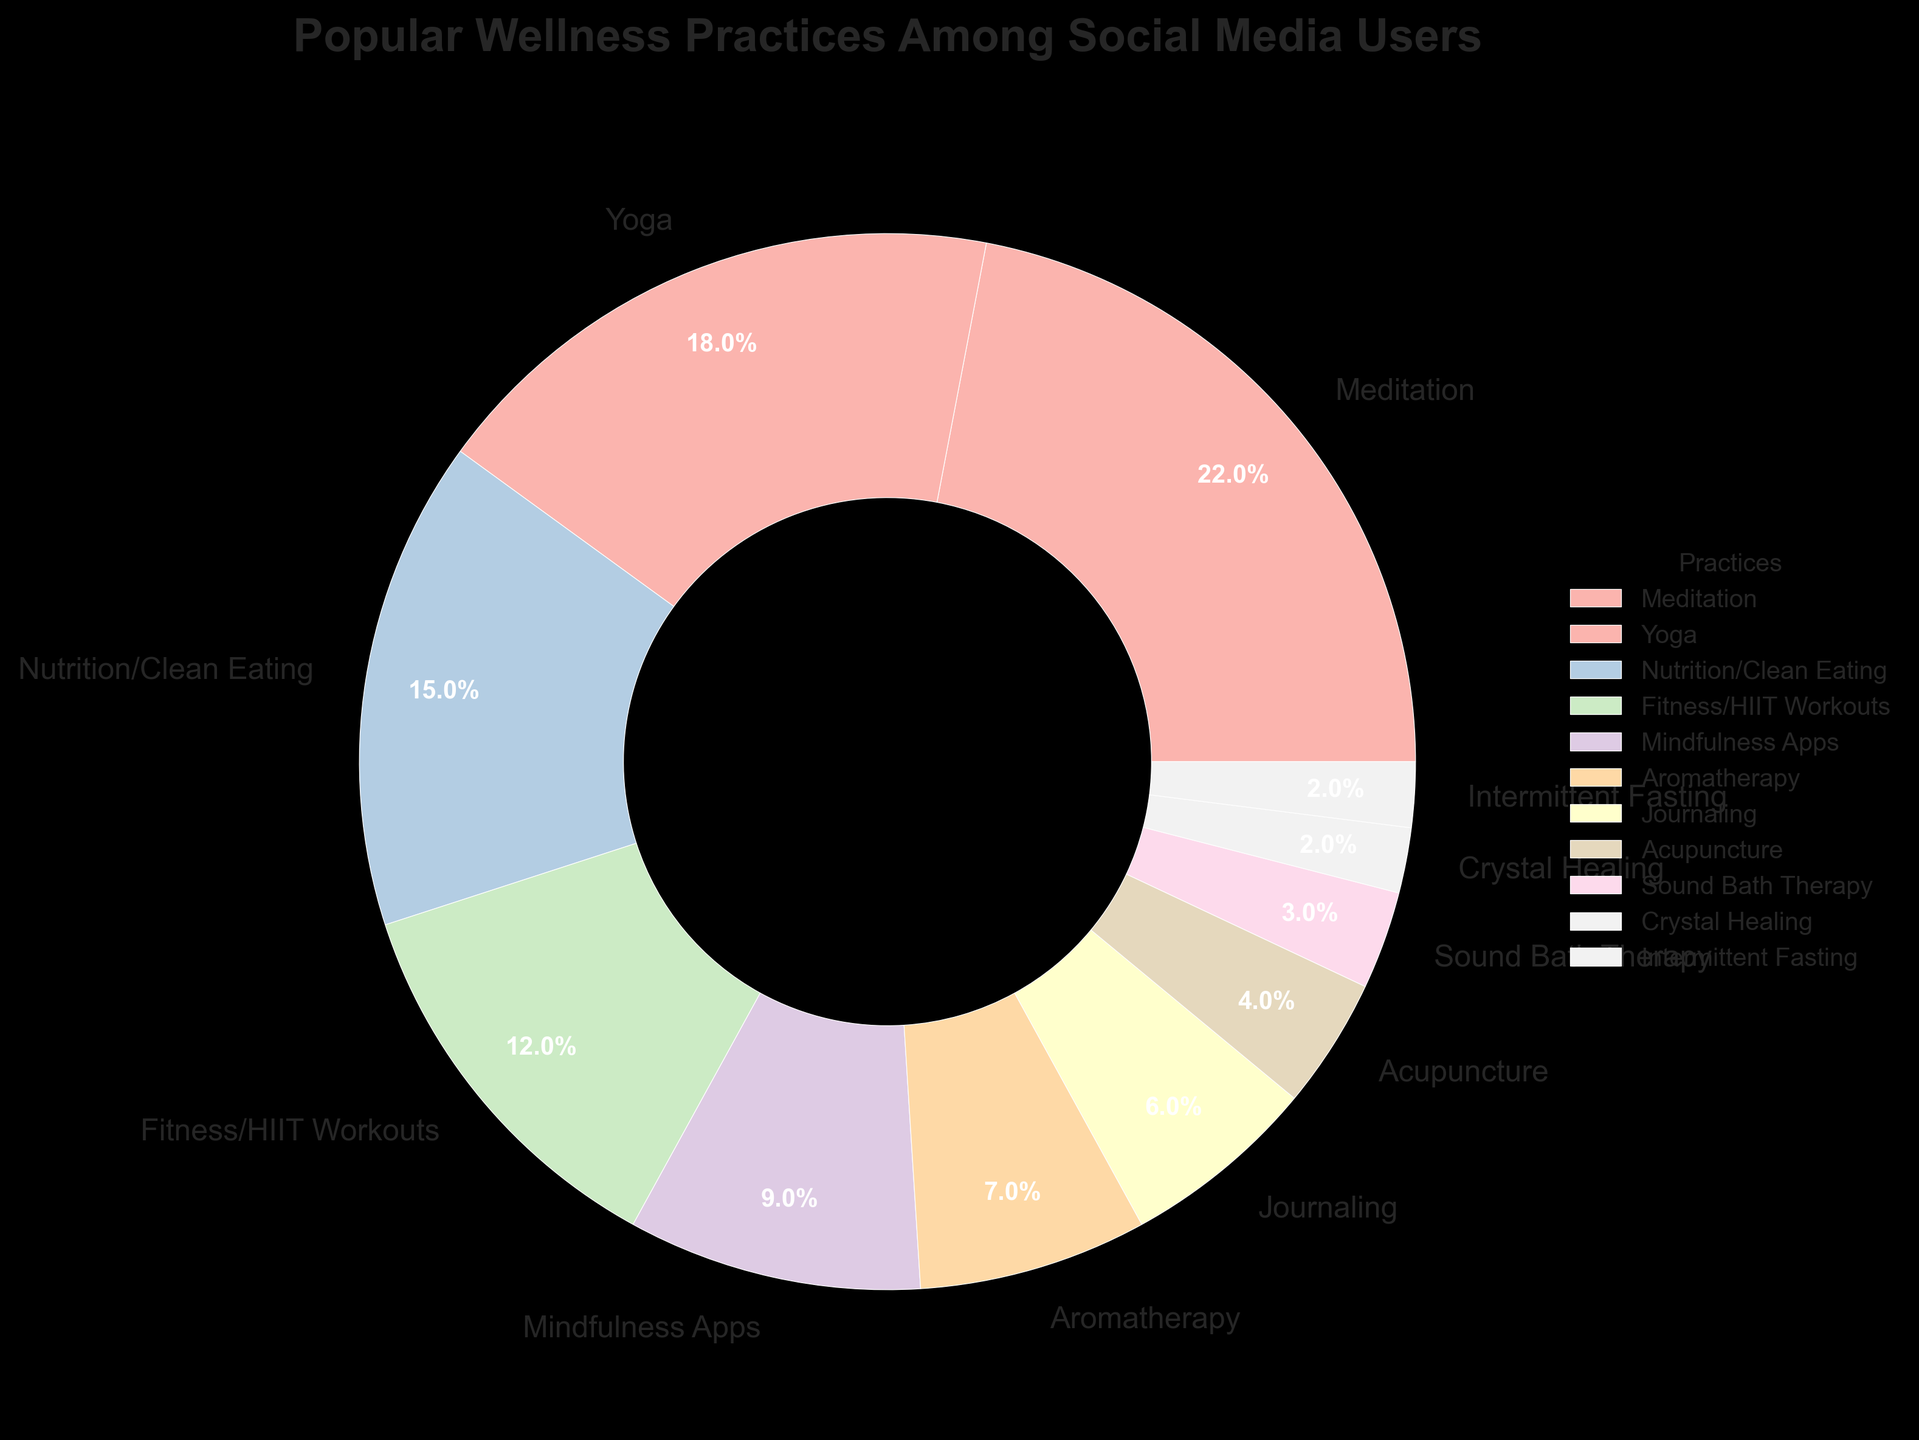What is the most popular wellness practice among social media users? The largest section of the pie chart represents the most popular wellness practice. Meditation occupies the largest portion of the chart. Therefore, the most popular wellness practice is Meditation.
Answer: Meditation Which wellness practice has a percentage of 9%? By examining the labels in the pie chart, we can find that Mindfulness Apps is the practice labeled with 9%.
Answer: Mindfulness Apps How much more popular is meditation compared to crystal healing? Meditation has a percentage of 22%, and Crystal Healing has a percentage of 2%. The difference in popularity is 22% - 2%, which results in 20%.
Answer: 20% What percent of users practice Yoga or Journaling? Yoga has a percentage of 18%, and Journaling has 6%. By adding these percentages, 18% + 6%, we get 24%.
Answer: 24% Which practice has the smallest representation in the pie chart? The smallest segment in the pie chart represents the practice with the smallest percentage. Crystal Healing occupies the smallest segment with 2%.
Answer: Crystal Healing How do the combined percentages of Fitness/HIIT Workouts and Nutrition/Clean Eating compare to Meditation? Fitness/HIIT Workouts has a percentage of 12% and Nutrition/Clean Eating has 15%. Combined, this is 12% + 15% = 27%. Meditation alone is 22%. Therefore, the combined percentage (27%) is greater than Meditation (22%).
Answer: 27% > 22% Identify two practices that together make up exactly 15% of the wellness practices. Upon examining the pie chart, we find that Acupuncture and Sound Bath Therapy represent percentages of 4% and 3% respectively. Together, 4% + 3% = 7%, which isn't sufficient. Similarly, no other combination of two practices sums exactly to 15%. But reviewing Journerling (6%) and Aromatherapy (9%) we get 6% + 9% = 15%
Answer: Journaling and Aromatherapy What is the difference in percentage between Yoga and Acupuncture? Yoga has a percentage of 18%, while Acupuncture has 4%. By subtracting the smaller value from the larger one, 18% - 4%, the difference in percentage is 14%.
Answer: 14% Which practices combine to make up 44% of the total? Reviewing the table, Meditation is at 22%, Yoga is at 18%, and Nutrition/Clean Eating is at 15%. Summing Meditation (22%) and Yoga (18%), we get 40%. We then examine the next highest value, which Fitness/HIIT Workouts (12%) that if under Nutrition we get 37%. So combining Nutrition at 15% we see 22%+18%+15% which sums to 45%.
Answer: Meditation and Yoga 